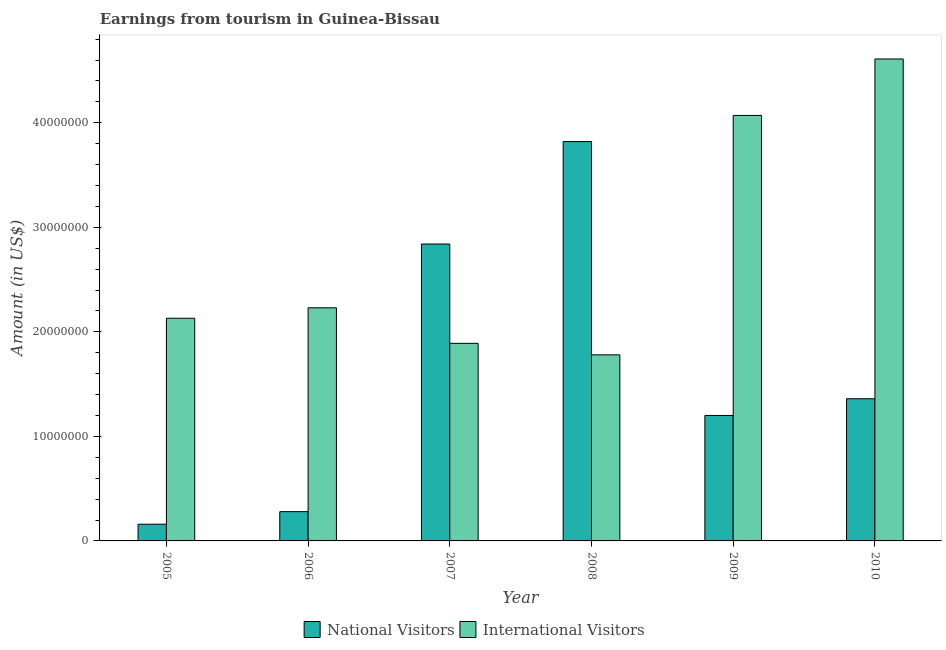How many different coloured bars are there?
Your answer should be compact. 2. Are the number of bars per tick equal to the number of legend labels?
Offer a very short reply. Yes. How many bars are there on the 6th tick from the left?
Ensure brevity in your answer.  2. How many bars are there on the 1st tick from the right?
Ensure brevity in your answer.  2. In how many cases, is the number of bars for a given year not equal to the number of legend labels?
Provide a short and direct response. 0. What is the amount earned from international visitors in 2006?
Keep it short and to the point. 2.23e+07. Across all years, what is the maximum amount earned from national visitors?
Keep it short and to the point. 3.82e+07. Across all years, what is the minimum amount earned from international visitors?
Your answer should be compact. 1.78e+07. In which year was the amount earned from national visitors maximum?
Provide a succinct answer. 2008. What is the total amount earned from international visitors in the graph?
Give a very brief answer. 1.67e+08. What is the difference between the amount earned from international visitors in 2006 and that in 2009?
Your response must be concise. -1.84e+07. What is the difference between the amount earned from international visitors in 2008 and the amount earned from national visitors in 2010?
Give a very brief answer. -2.83e+07. What is the average amount earned from international visitors per year?
Offer a terse response. 2.78e+07. In the year 2007, what is the difference between the amount earned from national visitors and amount earned from international visitors?
Your response must be concise. 0. In how many years, is the amount earned from international visitors greater than 28000000 US$?
Your response must be concise. 2. What is the ratio of the amount earned from national visitors in 2005 to that in 2010?
Offer a very short reply. 0.12. Is the difference between the amount earned from national visitors in 2005 and 2006 greater than the difference between the amount earned from international visitors in 2005 and 2006?
Keep it short and to the point. No. What is the difference between the highest and the second highest amount earned from international visitors?
Keep it short and to the point. 5.40e+06. What is the difference between the highest and the lowest amount earned from national visitors?
Your answer should be very brief. 3.66e+07. Is the sum of the amount earned from national visitors in 2007 and 2008 greater than the maximum amount earned from international visitors across all years?
Keep it short and to the point. Yes. What does the 2nd bar from the left in 2008 represents?
Offer a very short reply. International Visitors. What does the 2nd bar from the right in 2007 represents?
Your response must be concise. National Visitors. How many bars are there?
Keep it short and to the point. 12. Are all the bars in the graph horizontal?
Make the answer very short. No. How many years are there in the graph?
Make the answer very short. 6. What is the difference between two consecutive major ticks on the Y-axis?
Offer a terse response. 1.00e+07. Are the values on the major ticks of Y-axis written in scientific E-notation?
Offer a very short reply. No. Does the graph contain any zero values?
Give a very brief answer. No. Does the graph contain grids?
Give a very brief answer. No. What is the title of the graph?
Your response must be concise. Earnings from tourism in Guinea-Bissau. Does "Enforce a contract" appear as one of the legend labels in the graph?
Your answer should be very brief. No. What is the label or title of the X-axis?
Your answer should be compact. Year. What is the label or title of the Y-axis?
Offer a terse response. Amount (in US$). What is the Amount (in US$) in National Visitors in 2005?
Offer a very short reply. 1.60e+06. What is the Amount (in US$) in International Visitors in 2005?
Offer a very short reply. 2.13e+07. What is the Amount (in US$) in National Visitors in 2006?
Offer a very short reply. 2.80e+06. What is the Amount (in US$) in International Visitors in 2006?
Your answer should be very brief. 2.23e+07. What is the Amount (in US$) in National Visitors in 2007?
Provide a short and direct response. 2.84e+07. What is the Amount (in US$) in International Visitors in 2007?
Your answer should be compact. 1.89e+07. What is the Amount (in US$) of National Visitors in 2008?
Provide a succinct answer. 3.82e+07. What is the Amount (in US$) in International Visitors in 2008?
Offer a very short reply. 1.78e+07. What is the Amount (in US$) in National Visitors in 2009?
Your response must be concise. 1.20e+07. What is the Amount (in US$) of International Visitors in 2009?
Offer a terse response. 4.07e+07. What is the Amount (in US$) in National Visitors in 2010?
Your response must be concise. 1.36e+07. What is the Amount (in US$) of International Visitors in 2010?
Your answer should be very brief. 4.61e+07. Across all years, what is the maximum Amount (in US$) of National Visitors?
Your answer should be very brief. 3.82e+07. Across all years, what is the maximum Amount (in US$) in International Visitors?
Your answer should be compact. 4.61e+07. Across all years, what is the minimum Amount (in US$) in National Visitors?
Make the answer very short. 1.60e+06. Across all years, what is the minimum Amount (in US$) in International Visitors?
Offer a terse response. 1.78e+07. What is the total Amount (in US$) of National Visitors in the graph?
Your answer should be very brief. 9.66e+07. What is the total Amount (in US$) in International Visitors in the graph?
Provide a succinct answer. 1.67e+08. What is the difference between the Amount (in US$) of National Visitors in 2005 and that in 2006?
Give a very brief answer. -1.20e+06. What is the difference between the Amount (in US$) in International Visitors in 2005 and that in 2006?
Your response must be concise. -1.00e+06. What is the difference between the Amount (in US$) of National Visitors in 2005 and that in 2007?
Your answer should be very brief. -2.68e+07. What is the difference between the Amount (in US$) of International Visitors in 2005 and that in 2007?
Give a very brief answer. 2.40e+06. What is the difference between the Amount (in US$) of National Visitors in 2005 and that in 2008?
Your response must be concise. -3.66e+07. What is the difference between the Amount (in US$) of International Visitors in 2005 and that in 2008?
Offer a terse response. 3.50e+06. What is the difference between the Amount (in US$) of National Visitors in 2005 and that in 2009?
Provide a short and direct response. -1.04e+07. What is the difference between the Amount (in US$) of International Visitors in 2005 and that in 2009?
Ensure brevity in your answer.  -1.94e+07. What is the difference between the Amount (in US$) of National Visitors in 2005 and that in 2010?
Give a very brief answer. -1.20e+07. What is the difference between the Amount (in US$) in International Visitors in 2005 and that in 2010?
Offer a terse response. -2.48e+07. What is the difference between the Amount (in US$) in National Visitors in 2006 and that in 2007?
Your response must be concise. -2.56e+07. What is the difference between the Amount (in US$) of International Visitors in 2006 and that in 2007?
Give a very brief answer. 3.40e+06. What is the difference between the Amount (in US$) in National Visitors in 2006 and that in 2008?
Offer a very short reply. -3.54e+07. What is the difference between the Amount (in US$) in International Visitors in 2006 and that in 2008?
Your answer should be compact. 4.50e+06. What is the difference between the Amount (in US$) of National Visitors in 2006 and that in 2009?
Offer a very short reply. -9.20e+06. What is the difference between the Amount (in US$) in International Visitors in 2006 and that in 2009?
Your response must be concise. -1.84e+07. What is the difference between the Amount (in US$) in National Visitors in 2006 and that in 2010?
Your answer should be compact. -1.08e+07. What is the difference between the Amount (in US$) of International Visitors in 2006 and that in 2010?
Provide a short and direct response. -2.38e+07. What is the difference between the Amount (in US$) in National Visitors in 2007 and that in 2008?
Give a very brief answer. -9.80e+06. What is the difference between the Amount (in US$) of International Visitors in 2007 and that in 2008?
Keep it short and to the point. 1.10e+06. What is the difference between the Amount (in US$) of National Visitors in 2007 and that in 2009?
Your response must be concise. 1.64e+07. What is the difference between the Amount (in US$) in International Visitors in 2007 and that in 2009?
Provide a short and direct response. -2.18e+07. What is the difference between the Amount (in US$) in National Visitors in 2007 and that in 2010?
Make the answer very short. 1.48e+07. What is the difference between the Amount (in US$) in International Visitors in 2007 and that in 2010?
Provide a succinct answer. -2.72e+07. What is the difference between the Amount (in US$) of National Visitors in 2008 and that in 2009?
Offer a terse response. 2.62e+07. What is the difference between the Amount (in US$) of International Visitors in 2008 and that in 2009?
Provide a short and direct response. -2.29e+07. What is the difference between the Amount (in US$) of National Visitors in 2008 and that in 2010?
Provide a succinct answer. 2.46e+07. What is the difference between the Amount (in US$) in International Visitors in 2008 and that in 2010?
Make the answer very short. -2.83e+07. What is the difference between the Amount (in US$) in National Visitors in 2009 and that in 2010?
Your answer should be very brief. -1.60e+06. What is the difference between the Amount (in US$) in International Visitors in 2009 and that in 2010?
Your response must be concise. -5.40e+06. What is the difference between the Amount (in US$) in National Visitors in 2005 and the Amount (in US$) in International Visitors in 2006?
Your answer should be compact. -2.07e+07. What is the difference between the Amount (in US$) in National Visitors in 2005 and the Amount (in US$) in International Visitors in 2007?
Give a very brief answer. -1.73e+07. What is the difference between the Amount (in US$) in National Visitors in 2005 and the Amount (in US$) in International Visitors in 2008?
Give a very brief answer. -1.62e+07. What is the difference between the Amount (in US$) of National Visitors in 2005 and the Amount (in US$) of International Visitors in 2009?
Your answer should be very brief. -3.91e+07. What is the difference between the Amount (in US$) of National Visitors in 2005 and the Amount (in US$) of International Visitors in 2010?
Your answer should be compact. -4.45e+07. What is the difference between the Amount (in US$) of National Visitors in 2006 and the Amount (in US$) of International Visitors in 2007?
Offer a very short reply. -1.61e+07. What is the difference between the Amount (in US$) of National Visitors in 2006 and the Amount (in US$) of International Visitors in 2008?
Keep it short and to the point. -1.50e+07. What is the difference between the Amount (in US$) of National Visitors in 2006 and the Amount (in US$) of International Visitors in 2009?
Your answer should be compact. -3.79e+07. What is the difference between the Amount (in US$) in National Visitors in 2006 and the Amount (in US$) in International Visitors in 2010?
Provide a short and direct response. -4.33e+07. What is the difference between the Amount (in US$) in National Visitors in 2007 and the Amount (in US$) in International Visitors in 2008?
Provide a succinct answer. 1.06e+07. What is the difference between the Amount (in US$) of National Visitors in 2007 and the Amount (in US$) of International Visitors in 2009?
Keep it short and to the point. -1.23e+07. What is the difference between the Amount (in US$) of National Visitors in 2007 and the Amount (in US$) of International Visitors in 2010?
Make the answer very short. -1.77e+07. What is the difference between the Amount (in US$) in National Visitors in 2008 and the Amount (in US$) in International Visitors in 2009?
Your answer should be compact. -2.50e+06. What is the difference between the Amount (in US$) of National Visitors in 2008 and the Amount (in US$) of International Visitors in 2010?
Your answer should be very brief. -7.90e+06. What is the difference between the Amount (in US$) in National Visitors in 2009 and the Amount (in US$) in International Visitors in 2010?
Your answer should be very brief. -3.41e+07. What is the average Amount (in US$) in National Visitors per year?
Make the answer very short. 1.61e+07. What is the average Amount (in US$) in International Visitors per year?
Ensure brevity in your answer.  2.78e+07. In the year 2005, what is the difference between the Amount (in US$) of National Visitors and Amount (in US$) of International Visitors?
Offer a terse response. -1.97e+07. In the year 2006, what is the difference between the Amount (in US$) in National Visitors and Amount (in US$) in International Visitors?
Your answer should be very brief. -1.95e+07. In the year 2007, what is the difference between the Amount (in US$) of National Visitors and Amount (in US$) of International Visitors?
Provide a short and direct response. 9.50e+06. In the year 2008, what is the difference between the Amount (in US$) in National Visitors and Amount (in US$) in International Visitors?
Provide a short and direct response. 2.04e+07. In the year 2009, what is the difference between the Amount (in US$) in National Visitors and Amount (in US$) in International Visitors?
Offer a very short reply. -2.87e+07. In the year 2010, what is the difference between the Amount (in US$) in National Visitors and Amount (in US$) in International Visitors?
Make the answer very short. -3.25e+07. What is the ratio of the Amount (in US$) in National Visitors in 2005 to that in 2006?
Give a very brief answer. 0.57. What is the ratio of the Amount (in US$) of International Visitors in 2005 to that in 2006?
Provide a succinct answer. 0.96. What is the ratio of the Amount (in US$) of National Visitors in 2005 to that in 2007?
Your answer should be compact. 0.06. What is the ratio of the Amount (in US$) of International Visitors in 2005 to that in 2007?
Make the answer very short. 1.13. What is the ratio of the Amount (in US$) in National Visitors in 2005 to that in 2008?
Keep it short and to the point. 0.04. What is the ratio of the Amount (in US$) of International Visitors in 2005 to that in 2008?
Provide a short and direct response. 1.2. What is the ratio of the Amount (in US$) in National Visitors in 2005 to that in 2009?
Your response must be concise. 0.13. What is the ratio of the Amount (in US$) of International Visitors in 2005 to that in 2009?
Your answer should be very brief. 0.52. What is the ratio of the Amount (in US$) in National Visitors in 2005 to that in 2010?
Provide a short and direct response. 0.12. What is the ratio of the Amount (in US$) of International Visitors in 2005 to that in 2010?
Your answer should be very brief. 0.46. What is the ratio of the Amount (in US$) of National Visitors in 2006 to that in 2007?
Give a very brief answer. 0.1. What is the ratio of the Amount (in US$) of International Visitors in 2006 to that in 2007?
Your response must be concise. 1.18. What is the ratio of the Amount (in US$) in National Visitors in 2006 to that in 2008?
Your answer should be very brief. 0.07. What is the ratio of the Amount (in US$) of International Visitors in 2006 to that in 2008?
Keep it short and to the point. 1.25. What is the ratio of the Amount (in US$) of National Visitors in 2006 to that in 2009?
Keep it short and to the point. 0.23. What is the ratio of the Amount (in US$) in International Visitors in 2006 to that in 2009?
Keep it short and to the point. 0.55. What is the ratio of the Amount (in US$) in National Visitors in 2006 to that in 2010?
Give a very brief answer. 0.21. What is the ratio of the Amount (in US$) of International Visitors in 2006 to that in 2010?
Offer a very short reply. 0.48. What is the ratio of the Amount (in US$) in National Visitors in 2007 to that in 2008?
Provide a short and direct response. 0.74. What is the ratio of the Amount (in US$) in International Visitors in 2007 to that in 2008?
Give a very brief answer. 1.06. What is the ratio of the Amount (in US$) in National Visitors in 2007 to that in 2009?
Provide a succinct answer. 2.37. What is the ratio of the Amount (in US$) in International Visitors in 2007 to that in 2009?
Your answer should be compact. 0.46. What is the ratio of the Amount (in US$) of National Visitors in 2007 to that in 2010?
Make the answer very short. 2.09. What is the ratio of the Amount (in US$) in International Visitors in 2007 to that in 2010?
Your answer should be compact. 0.41. What is the ratio of the Amount (in US$) of National Visitors in 2008 to that in 2009?
Keep it short and to the point. 3.18. What is the ratio of the Amount (in US$) of International Visitors in 2008 to that in 2009?
Your response must be concise. 0.44. What is the ratio of the Amount (in US$) of National Visitors in 2008 to that in 2010?
Your answer should be compact. 2.81. What is the ratio of the Amount (in US$) of International Visitors in 2008 to that in 2010?
Your answer should be very brief. 0.39. What is the ratio of the Amount (in US$) of National Visitors in 2009 to that in 2010?
Your answer should be very brief. 0.88. What is the ratio of the Amount (in US$) in International Visitors in 2009 to that in 2010?
Your answer should be compact. 0.88. What is the difference between the highest and the second highest Amount (in US$) in National Visitors?
Your answer should be very brief. 9.80e+06. What is the difference between the highest and the second highest Amount (in US$) of International Visitors?
Make the answer very short. 5.40e+06. What is the difference between the highest and the lowest Amount (in US$) of National Visitors?
Your response must be concise. 3.66e+07. What is the difference between the highest and the lowest Amount (in US$) of International Visitors?
Your answer should be compact. 2.83e+07. 